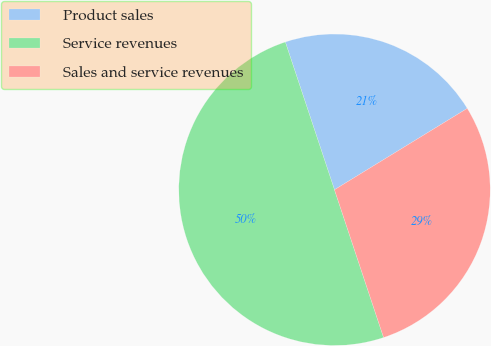Convert chart to OTSL. <chart><loc_0><loc_0><loc_500><loc_500><pie_chart><fcel>Product sales<fcel>Service revenues<fcel>Sales and service revenues<nl><fcel>21.36%<fcel>50.0%<fcel>28.64%<nl></chart> 